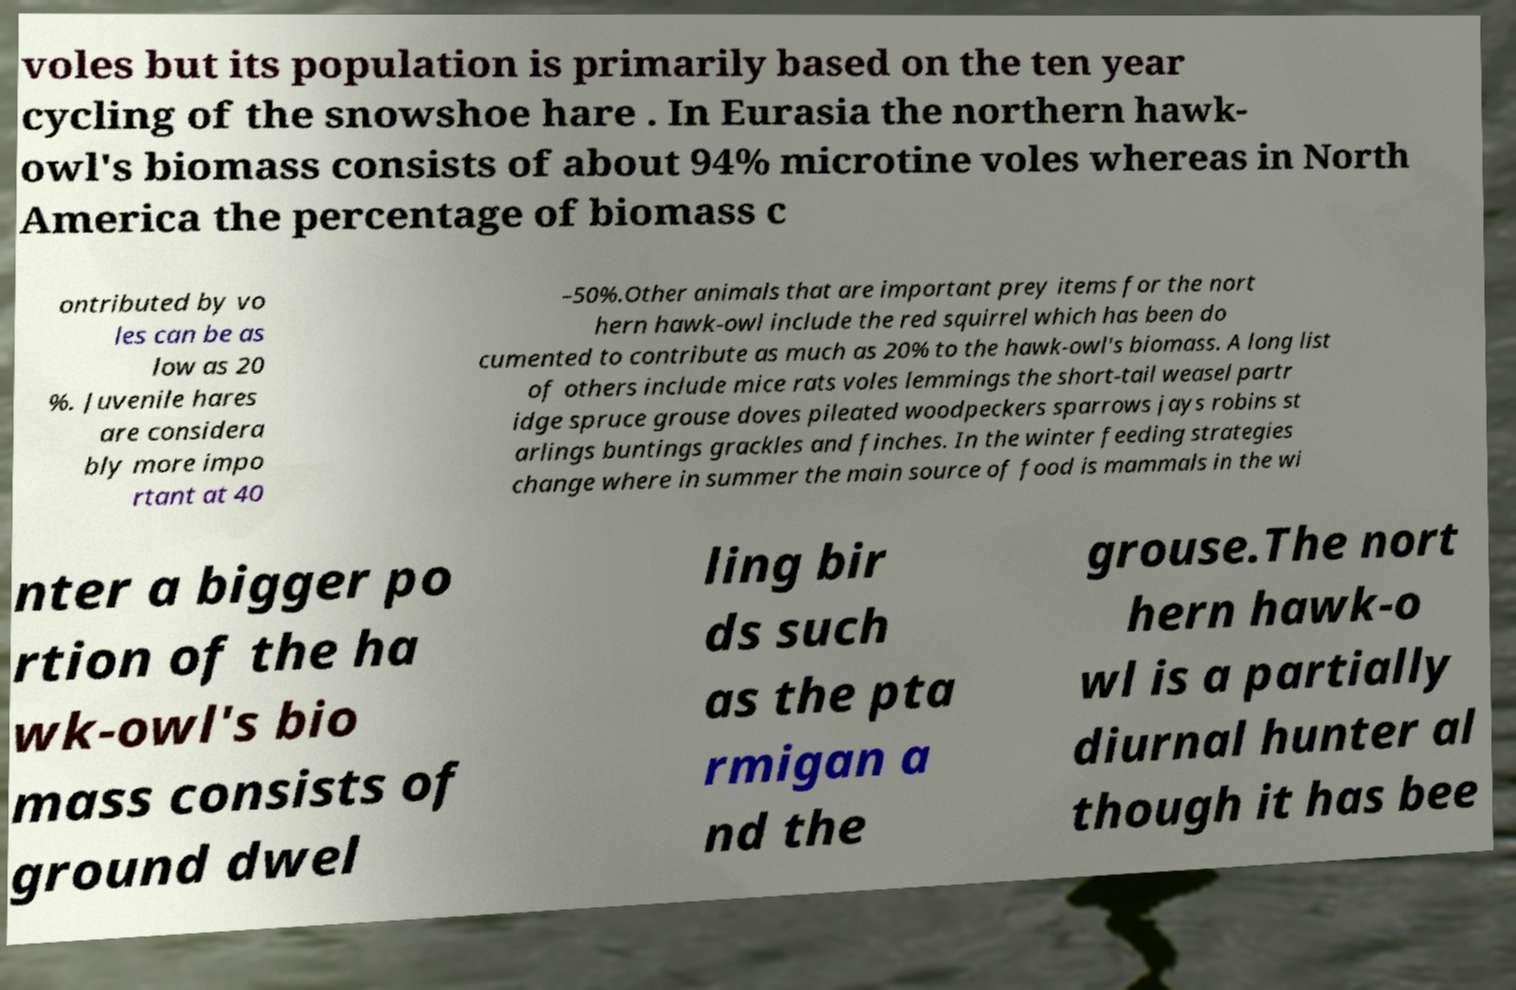There's text embedded in this image that I need extracted. Can you transcribe it verbatim? voles but its population is primarily based on the ten year cycling of the snowshoe hare . In Eurasia the northern hawk- owl's biomass consists of about 94% microtine voles whereas in North America the percentage of biomass c ontributed by vo les can be as low as 20 %. Juvenile hares are considera bly more impo rtant at 40 –50%.Other animals that are important prey items for the nort hern hawk-owl include the red squirrel which has been do cumented to contribute as much as 20% to the hawk-owl's biomass. A long list of others include mice rats voles lemmings the short-tail weasel partr idge spruce grouse doves pileated woodpeckers sparrows jays robins st arlings buntings grackles and finches. In the winter feeding strategies change where in summer the main source of food is mammals in the wi nter a bigger po rtion of the ha wk-owl's bio mass consists of ground dwel ling bir ds such as the pta rmigan a nd the grouse.The nort hern hawk-o wl is a partially diurnal hunter al though it has bee 